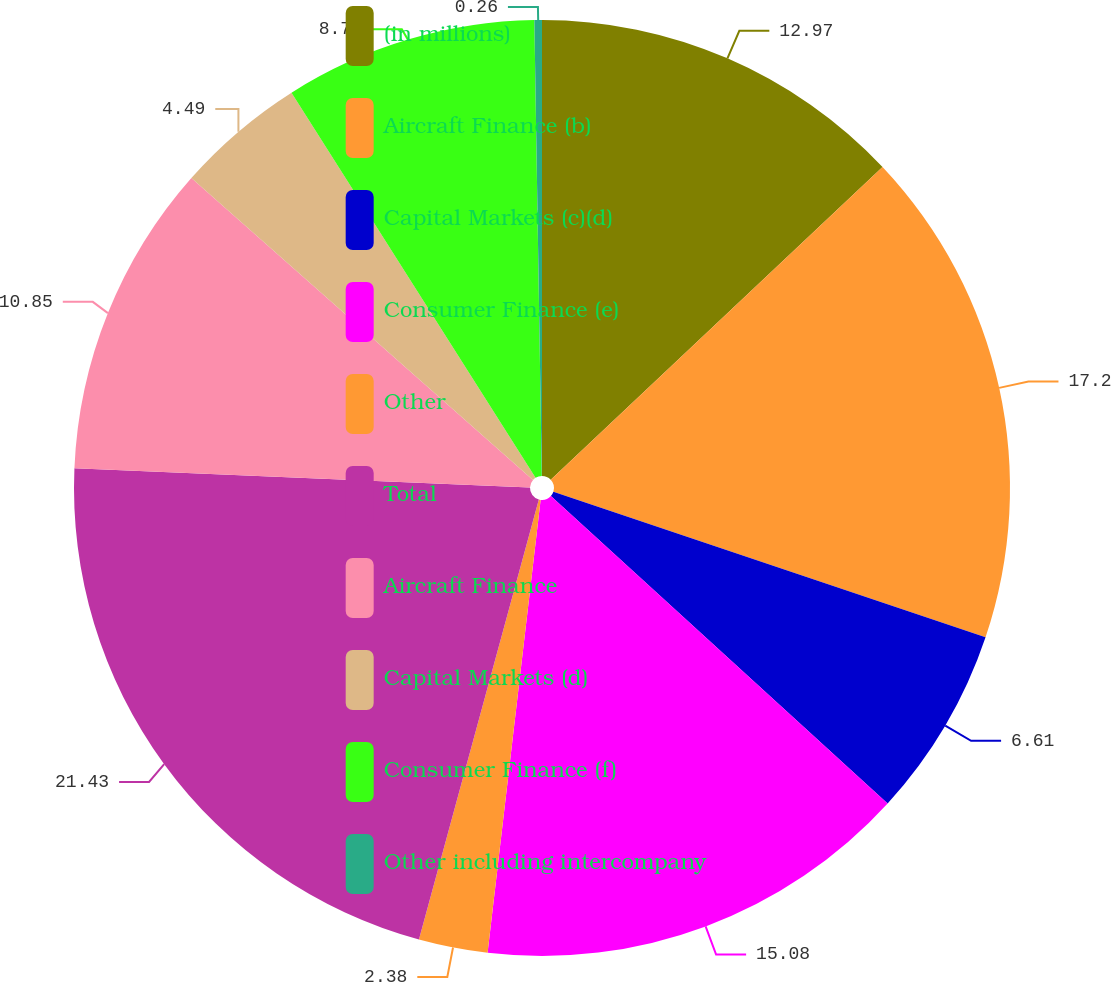Convert chart. <chart><loc_0><loc_0><loc_500><loc_500><pie_chart><fcel>(in millions)<fcel>Aircraft Finance (b)<fcel>Capital Markets (c)(d)<fcel>Consumer Finance (e)<fcel>Other<fcel>Total<fcel>Aircraft Finance<fcel>Capital Markets (d)<fcel>Consumer Finance (f)<fcel>Other including intercompany<nl><fcel>12.97%<fcel>17.2%<fcel>6.61%<fcel>15.08%<fcel>2.38%<fcel>21.44%<fcel>10.85%<fcel>4.49%<fcel>8.73%<fcel>0.26%<nl></chart> 